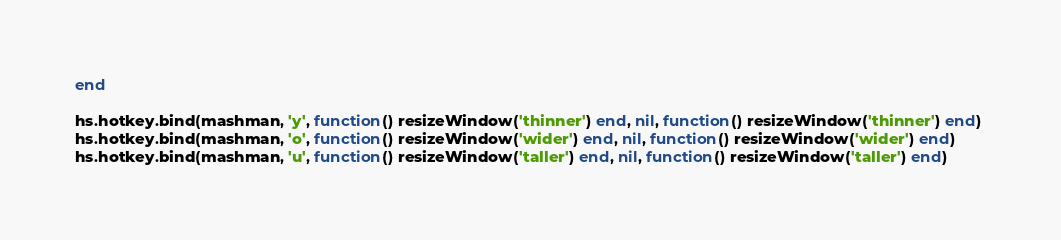<code> <loc_0><loc_0><loc_500><loc_500><_Lua_>end

hs.hotkey.bind(mashman, 'y', function() resizeWindow('thinner') end, nil, function() resizeWindow('thinner') end) 
hs.hotkey.bind(mashman, 'o', function() resizeWindow('wider') end, nil, function() resizeWindow('wider') end) 
hs.hotkey.bind(mashman, 'u', function() resizeWindow('taller') end, nil, function() resizeWindow('taller') end) </code> 